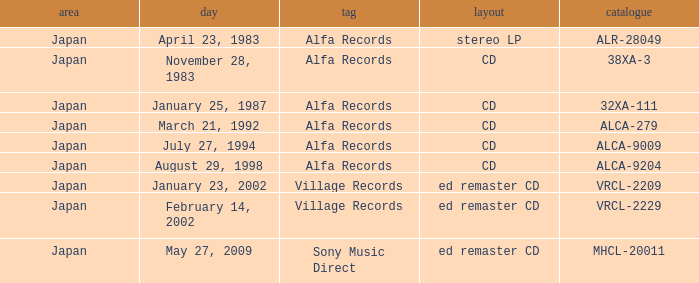Which date is in CD format? November 28, 1983, January 25, 1987, March 21, 1992, July 27, 1994, August 29, 1998. 